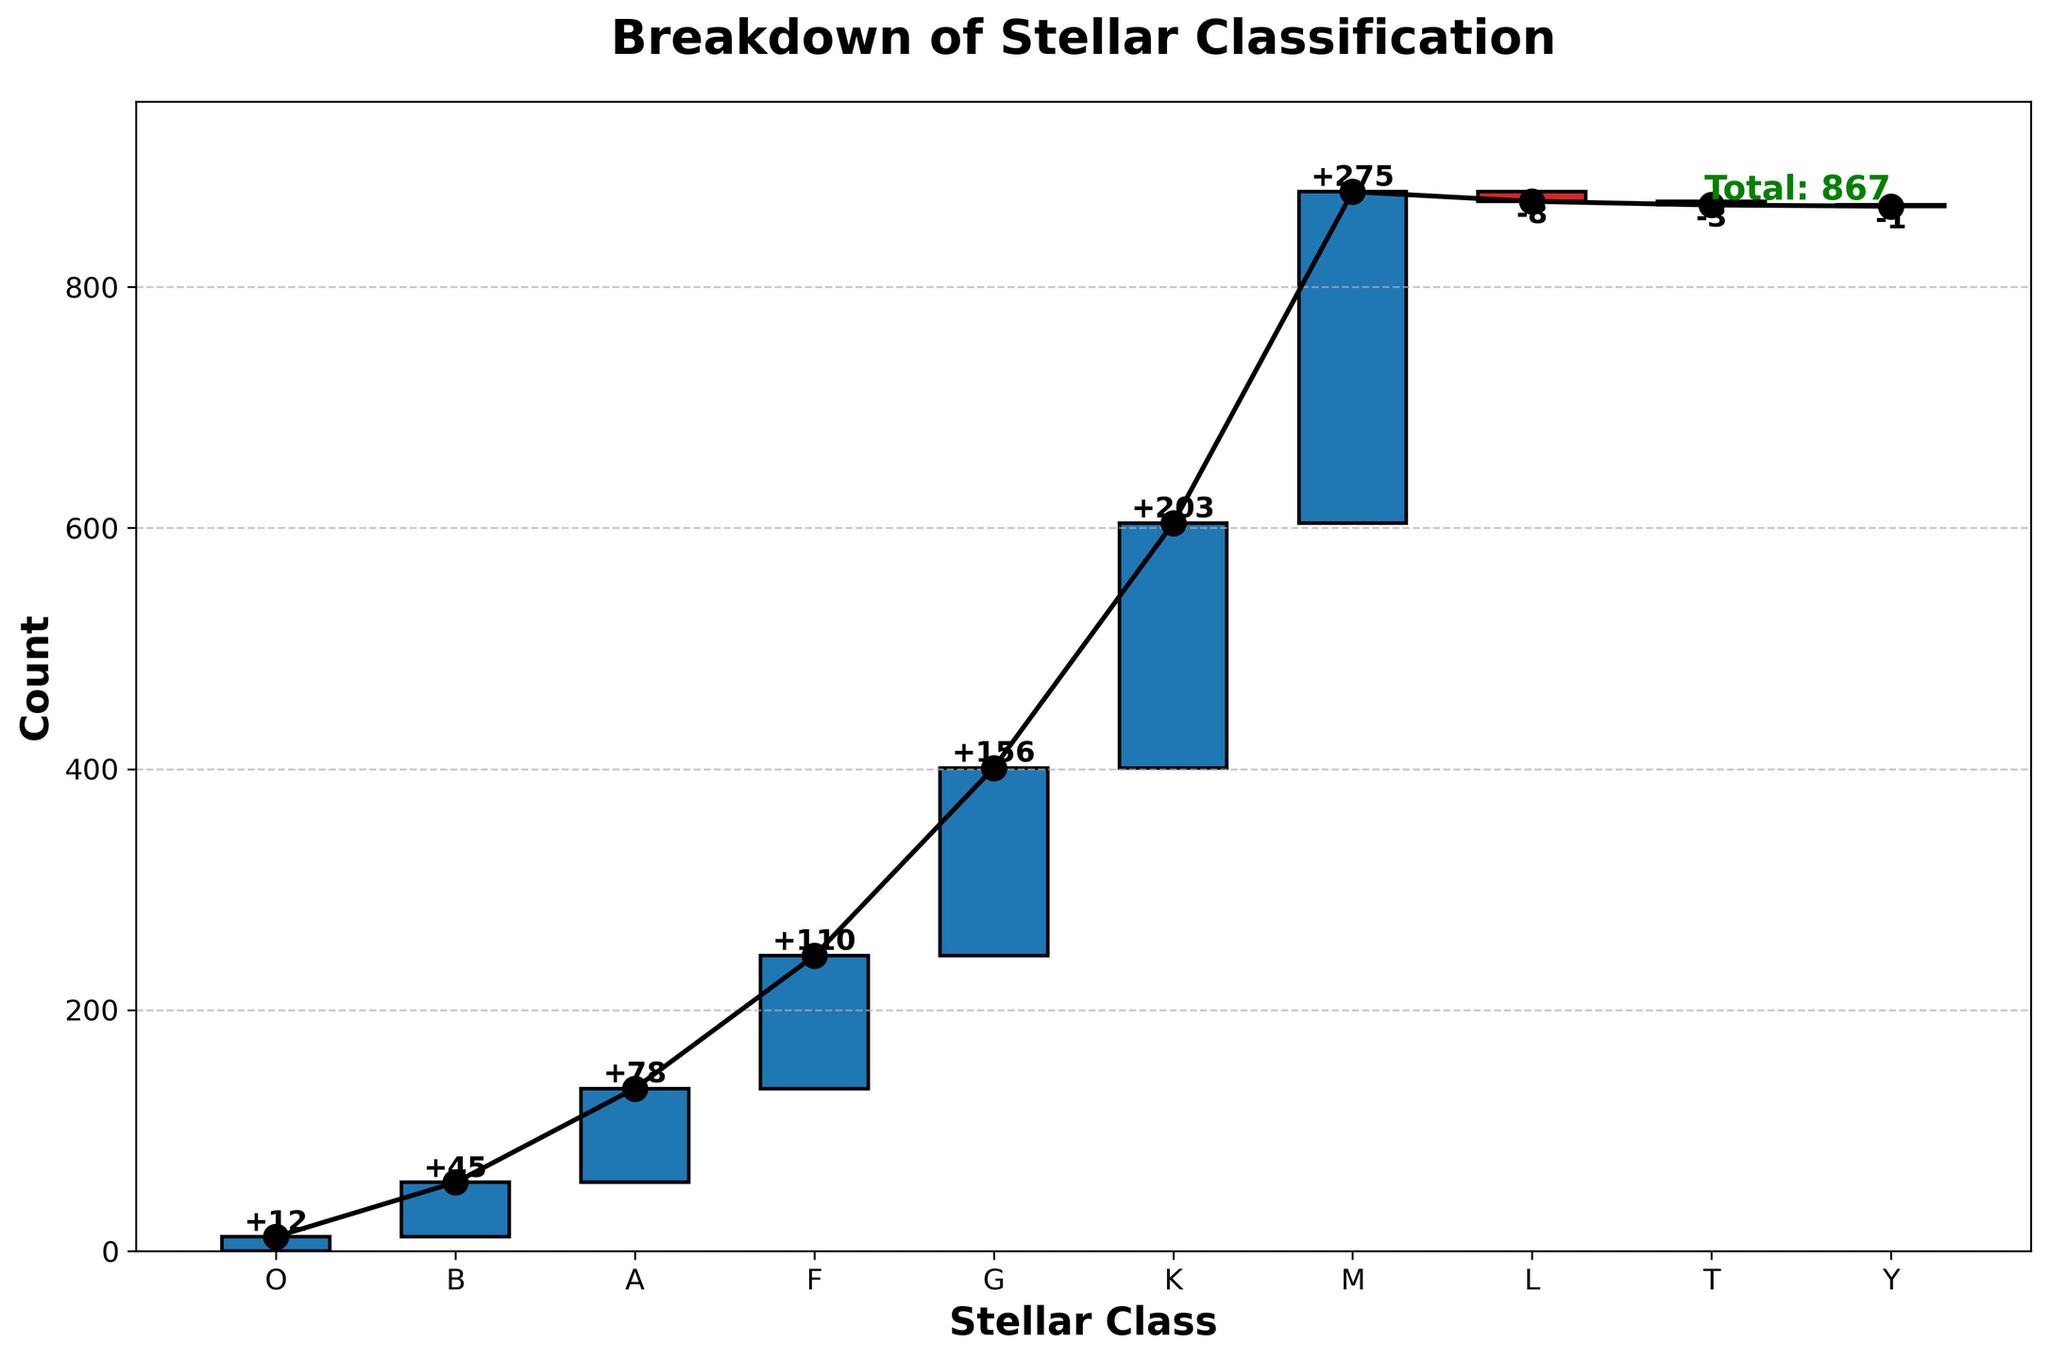What is the title of the chart? The title of the chart is usually located at the top of the figure and is used to describe the content of the chart. In this case, the title reads 'Breakdown of Stellar Classification'.
Answer: Breakdown of Stellar Classification What are the categories on the x-axis? The categories on the x-axis are the different types of stellar classes. In the chart, they are O, B, A, F, G, K, M, L, T, and Y.
Answer: O, B, A, F, G, K, M, L, T, Y Which stellar class has the highest count? To determine which stellar class has the highest count, look at the height of the bars representing each category. The tallest bar corresponds to the stellar class M.
Answer: M How much do the classes L, T, and Y contribute combined? To find the combined contribution of the classes L, T, and Y, add their individual counts together, taking note of negative values. L has -8, T has -3, and Y has -1. The sum is -8 + -3 + -1 = -12.
Answer: -12 How does the count of class B compare to class A? To compare the counts, look at the bars for class B and class A. The count for class B is 45, and for class A, it is 78. Thus, class A has a higher count than class B.
Answer: Class A has a higher count What is the cumulative count after the class G? The cumulative count includes all categories up to and including class G. Add the counts of O, B, A, F, and G: 12 + 45 + 78 + 110 + 156 = 401.
Answer: 401 What is the total count of all observed stars? The total count of all observed stars is usually indicated at the end or bottom of the chart. Here, it is specified as 'Total: 867'.
Answer: 867 Which classes have negative counts? In the chart, the classes with negative contributions are identifiable by their downward direction. Classes L, T, and Y have negative counts of -8, -3, and -1, respectively.
Answer: L, T, Y What's the difference in count between classes G and F? To find the difference, subtract the count of F from G: 156 (G) - 110 (F) = 46.
Answer: 46 What is the color coding used for positive and negative values? The color coding in the chart for positive values is usually different from that for negative values. Positive values are depicted in blue, while negative values are shown in red.
Answer: Blue for positive, Red for negative 